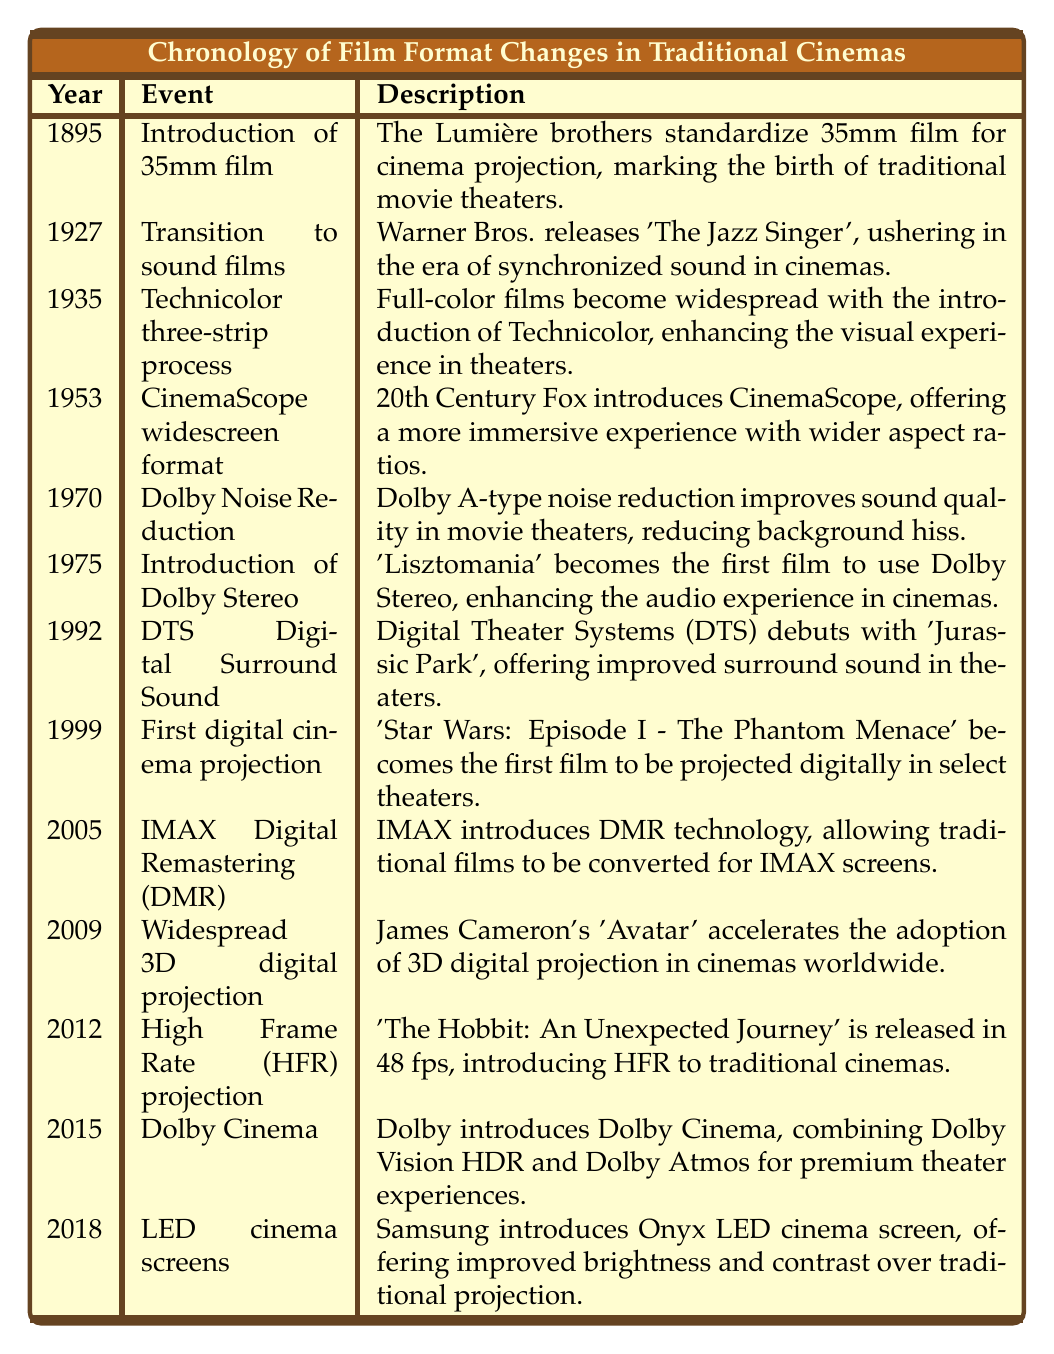What year did the Lumière brothers standardize 35mm film? The table lists the introduction of 35mm film as occurring in 1895.
Answer: 1895 What event marked the transition to sound films in cinemas? The event that marked the transition to sound films is listed as Warner Bros. releasing 'The Jazz Singer' in 1927.
Answer: Transition to sound films Which film was the first to use Dolby Stereo? According to the table, the first film to use Dolby Stereo is 'Lisztomania' in 1975.
Answer: 'Lisztomania' What is the time gap between the introduction of 35mm film and the first digital cinema projection? The introduction of 35mm film occurred in 1895 and the first digital cinema projection occurred in 1999. The time gap is 1999 - 1895 = 104 years.
Answer: 104 years Did Technicolor three-strip process become widespread before or after the introduction of Dolby Noise Reduction? The Technicolor three-strip process was introduced in 1935 and Dolby Noise Reduction occurred in 1970. Since 1935 is before 1970, Technicolor became widespread before Dolby.
Answer: Before What technological advancements occurred in cinemas between the years of 1953 and 2018? Between 1953 (CinemaScope) and 2018 (LED cinema screens), several advancements occurred: CinemaScope in 1953, Dolby Noise Reduction in 1970, Dolby Stereo in 1975, DTS Digital Surround Sound in 1992, first digital cinema projection in 1999, IMAX DMR in 2005, 3D digital projection in 2009, High Frame Rate projection in 2012, and Dolby Cinema in 2015. This shows a significant evolution in both visual and audio technologies over that period.
Answer: Multiple advancements What percentage of the listed events focus on audio improvements? There are 13 events, with 4 specific to audio improvements (Dolby Noise Reduction, Dolby Stereo, DTS Digital Surround Sound, and Dolby Cinema). The percentage is (4/13) * 100 ≈ 30.77%.
Answer: Approximately 30.77% Is 'Avatar' mentioned in the context of digital projection or audio improvements? The table mentions 'Avatar' in the context of widespread 3D digital projection in 2009.
Answer: Digital projection Which format introduced in this timeline offers a wider aspect ratio, CinemaScope or IMAX DMR? CinemaScope introduced in 1953 is specified for offering wider aspect ratios, while IMAX DMR is technology to convert films for IMAX screens without specifically stating aspect ratio differences in this table context. Therefore, based on the given information, CinemaScope offers a wider aspect ratio specifically.
Answer: CinemaScope 